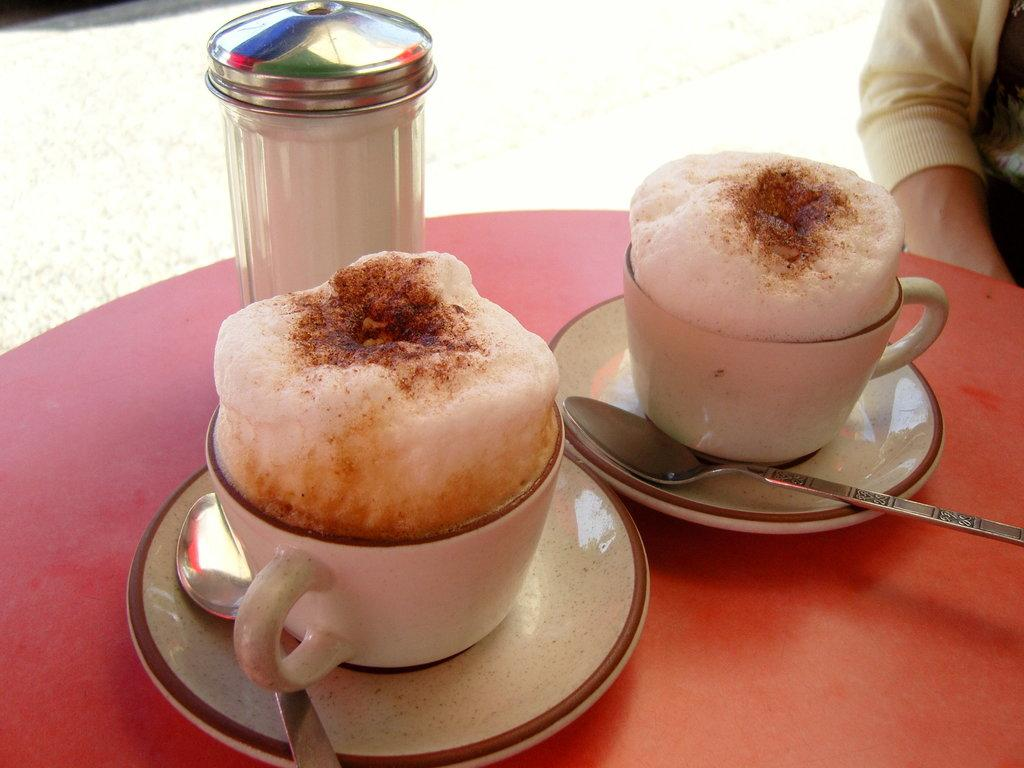What color is the table in the image? The table in the image is red. What type of beverages are on the table? There are two cappuccinos on the table. What other items can be seen on the table? There is a saucer, a spoon, and a sugar bottle on the table. What is the man wearing in the image? The man is wearing a dress in the image. What can be seen in the background of the image? There is a road visible in the image. What activity is the man doing with his nails in the image? There is no mention of nails or any activity involving nails in the image. 